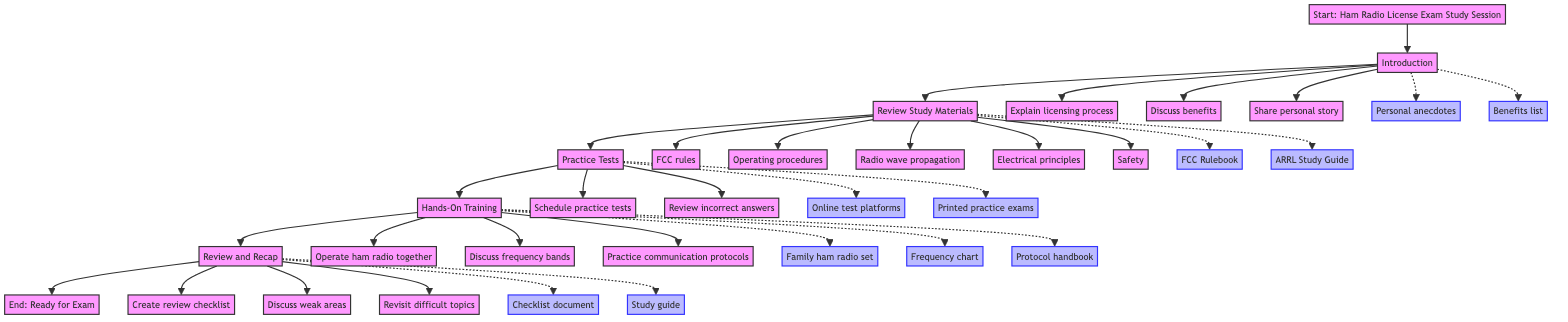What is the first step in the study session? The first step, as indicated in the flowchart, is "Introduction." This is the starting point of the entire study session process.
Answer: Introduction How many study material topics are listed? The flowchart outlines five specific study material topics: FCC rules, Operating procedures, Radio wave propagation, Electrical principles, and Safety. Therefore, the total number is five.
Answer: 5 Which activity follows the "Practice Tests" step? After "Practice Tests," the next step in the flowchart is "Hands-On Training." The flow indicates a direct progression from one step to the next.
Answer: Hands-On Training What resources are associated with the "Hands-On Training" step? The resources linked to the "Hands-On Training" step include: Family ham radio set, Frequency chart, and Protocol handbook. They provide essential support for practical learning.
Answer: Family ham radio set, Frequency chart, Protocol handbook What is the last activity listed in the "Review and Recap" step? The last activity for the "Review and Recap" step is "Revisit difficult topics." This activity signifies concluding the review process by focusing on challenging areas.
Answer: Revisit difficult topics What is the overall purpose of the diagram? The overall purpose of the diagram is to outline a structured process for conducting a Ham Radio License Exam Study Session with a child, detailing the necessary steps and activities involved.
Answer: Outline study process How many total steps are represented in the flowchart? The flowchart contains six main steps which are: Start, Introduction, Review Study Materials, Practice Tests, Hands-On Training, and Review and Recap, ending with the End step.
Answer: 6 Which resource is shared in the "Introduction" step? The resources shared in the "Introduction" step include Personal anecdotes and Benefits list. These resources help illustrate the importance of the ham radio license.
Answer: Personal anecdotes, Benefits list What type of activity is scheduled in the "Practice Tests" step? The activity scheduled in the "Practice Tests" step is "Schedule practice test sessions." This emphasizes preparation through exam simulation.
Answer: Schedule practice test sessions 